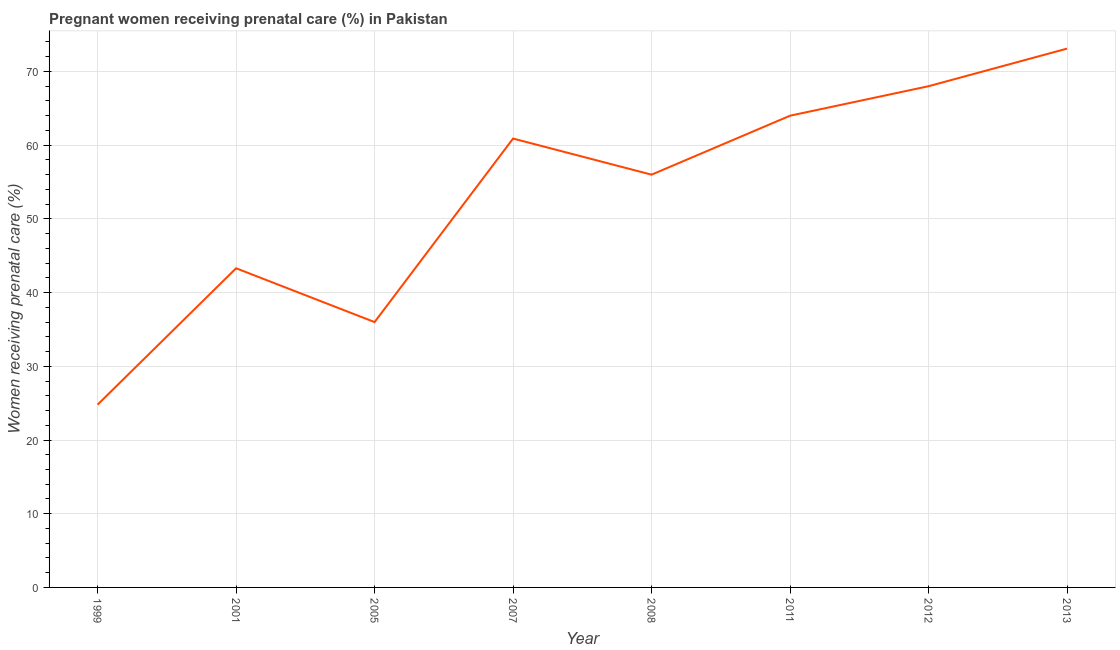What is the percentage of pregnant women receiving prenatal care in 2001?
Your answer should be very brief. 43.3. Across all years, what is the maximum percentage of pregnant women receiving prenatal care?
Your response must be concise. 73.1. Across all years, what is the minimum percentage of pregnant women receiving prenatal care?
Offer a terse response. 24.8. In which year was the percentage of pregnant women receiving prenatal care maximum?
Provide a short and direct response. 2013. What is the sum of the percentage of pregnant women receiving prenatal care?
Give a very brief answer. 426.1. What is the average percentage of pregnant women receiving prenatal care per year?
Your response must be concise. 53.26. What is the median percentage of pregnant women receiving prenatal care?
Make the answer very short. 58.45. Do a majority of the years between 2013 and 2005 (inclusive) have percentage of pregnant women receiving prenatal care greater than 22 %?
Make the answer very short. Yes. What is the ratio of the percentage of pregnant women receiving prenatal care in 2001 to that in 2011?
Make the answer very short. 0.68. What is the difference between the highest and the second highest percentage of pregnant women receiving prenatal care?
Ensure brevity in your answer.  5.1. What is the difference between the highest and the lowest percentage of pregnant women receiving prenatal care?
Your response must be concise. 48.3. In how many years, is the percentage of pregnant women receiving prenatal care greater than the average percentage of pregnant women receiving prenatal care taken over all years?
Your answer should be compact. 5. Are the values on the major ticks of Y-axis written in scientific E-notation?
Give a very brief answer. No. What is the title of the graph?
Make the answer very short. Pregnant women receiving prenatal care (%) in Pakistan. What is the label or title of the Y-axis?
Keep it short and to the point. Women receiving prenatal care (%). What is the Women receiving prenatal care (%) of 1999?
Give a very brief answer. 24.8. What is the Women receiving prenatal care (%) of 2001?
Provide a short and direct response. 43.3. What is the Women receiving prenatal care (%) of 2005?
Your response must be concise. 36. What is the Women receiving prenatal care (%) in 2007?
Your answer should be very brief. 60.9. What is the Women receiving prenatal care (%) in 2008?
Your response must be concise. 56. What is the Women receiving prenatal care (%) of 2011?
Provide a succinct answer. 64. What is the Women receiving prenatal care (%) in 2012?
Make the answer very short. 68. What is the Women receiving prenatal care (%) in 2013?
Ensure brevity in your answer.  73.1. What is the difference between the Women receiving prenatal care (%) in 1999 and 2001?
Give a very brief answer. -18.5. What is the difference between the Women receiving prenatal care (%) in 1999 and 2005?
Your answer should be compact. -11.2. What is the difference between the Women receiving prenatal care (%) in 1999 and 2007?
Make the answer very short. -36.1. What is the difference between the Women receiving prenatal care (%) in 1999 and 2008?
Offer a terse response. -31.2. What is the difference between the Women receiving prenatal care (%) in 1999 and 2011?
Your response must be concise. -39.2. What is the difference between the Women receiving prenatal care (%) in 1999 and 2012?
Your answer should be compact. -43.2. What is the difference between the Women receiving prenatal care (%) in 1999 and 2013?
Ensure brevity in your answer.  -48.3. What is the difference between the Women receiving prenatal care (%) in 2001 and 2007?
Ensure brevity in your answer.  -17.6. What is the difference between the Women receiving prenatal care (%) in 2001 and 2008?
Provide a short and direct response. -12.7. What is the difference between the Women receiving prenatal care (%) in 2001 and 2011?
Offer a very short reply. -20.7. What is the difference between the Women receiving prenatal care (%) in 2001 and 2012?
Make the answer very short. -24.7. What is the difference between the Women receiving prenatal care (%) in 2001 and 2013?
Your response must be concise. -29.8. What is the difference between the Women receiving prenatal care (%) in 2005 and 2007?
Give a very brief answer. -24.9. What is the difference between the Women receiving prenatal care (%) in 2005 and 2011?
Provide a short and direct response. -28. What is the difference between the Women receiving prenatal care (%) in 2005 and 2012?
Provide a short and direct response. -32. What is the difference between the Women receiving prenatal care (%) in 2005 and 2013?
Your answer should be compact. -37.1. What is the difference between the Women receiving prenatal care (%) in 2007 and 2011?
Provide a short and direct response. -3.1. What is the difference between the Women receiving prenatal care (%) in 2007 and 2013?
Provide a short and direct response. -12.2. What is the difference between the Women receiving prenatal care (%) in 2008 and 2011?
Your answer should be very brief. -8. What is the difference between the Women receiving prenatal care (%) in 2008 and 2013?
Offer a terse response. -17.1. What is the difference between the Women receiving prenatal care (%) in 2011 and 2012?
Provide a succinct answer. -4. What is the ratio of the Women receiving prenatal care (%) in 1999 to that in 2001?
Ensure brevity in your answer.  0.57. What is the ratio of the Women receiving prenatal care (%) in 1999 to that in 2005?
Offer a terse response. 0.69. What is the ratio of the Women receiving prenatal care (%) in 1999 to that in 2007?
Your answer should be very brief. 0.41. What is the ratio of the Women receiving prenatal care (%) in 1999 to that in 2008?
Provide a short and direct response. 0.44. What is the ratio of the Women receiving prenatal care (%) in 1999 to that in 2011?
Your answer should be compact. 0.39. What is the ratio of the Women receiving prenatal care (%) in 1999 to that in 2012?
Make the answer very short. 0.36. What is the ratio of the Women receiving prenatal care (%) in 1999 to that in 2013?
Offer a very short reply. 0.34. What is the ratio of the Women receiving prenatal care (%) in 2001 to that in 2005?
Ensure brevity in your answer.  1.2. What is the ratio of the Women receiving prenatal care (%) in 2001 to that in 2007?
Make the answer very short. 0.71. What is the ratio of the Women receiving prenatal care (%) in 2001 to that in 2008?
Provide a short and direct response. 0.77. What is the ratio of the Women receiving prenatal care (%) in 2001 to that in 2011?
Provide a short and direct response. 0.68. What is the ratio of the Women receiving prenatal care (%) in 2001 to that in 2012?
Your response must be concise. 0.64. What is the ratio of the Women receiving prenatal care (%) in 2001 to that in 2013?
Your answer should be compact. 0.59. What is the ratio of the Women receiving prenatal care (%) in 2005 to that in 2007?
Keep it short and to the point. 0.59. What is the ratio of the Women receiving prenatal care (%) in 2005 to that in 2008?
Offer a very short reply. 0.64. What is the ratio of the Women receiving prenatal care (%) in 2005 to that in 2011?
Provide a short and direct response. 0.56. What is the ratio of the Women receiving prenatal care (%) in 2005 to that in 2012?
Give a very brief answer. 0.53. What is the ratio of the Women receiving prenatal care (%) in 2005 to that in 2013?
Your answer should be very brief. 0.49. What is the ratio of the Women receiving prenatal care (%) in 2007 to that in 2008?
Provide a short and direct response. 1.09. What is the ratio of the Women receiving prenatal care (%) in 2007 to that in 2012?
Make the answer very short. 0.9. What is the ratio of the Women receiving prenatal care (%) in 2007 to that in 2013?
Your answer should be very brief. 0.83. What is the ratio of the Women receiving prenatal care (%) in 2008 to that in 2012?
Offer a terse response. 0.82. What is the ratio of the Women receiving prenatal care (%) in 2008 to that in 2013?
Your answer should be very brief. 0.77. What is the ratio of the Women receiving prenatal care (%) in 2011 to that in 2012?
Make the answer very short. 0.94. What is the ratio of the Women receiving prenatal care (%) in 2011 to that in 2013?
Make the answer very short. 0.88. 